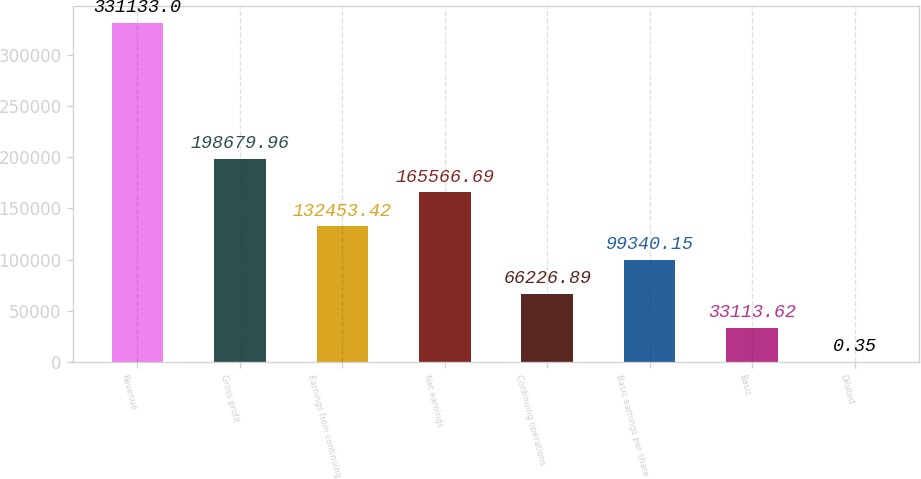<chart> <loc_0><loc_0><loc_500><loc_500><bar_chart><fcel>Revenue<fcel>Gross profit<fcel>Earnings from continuing<fcel>Net earnings<fcel>Continuing operations<fcel>Basic earnings per share<fcel>Basic<fcel>Diluted<nl><fcel>331133<fcel>198680<fcel>132453<fcel>165567<fcel>66226.9<fcel>99340.1<fcel>33113.6<fcel>0.35<nl></chart> 